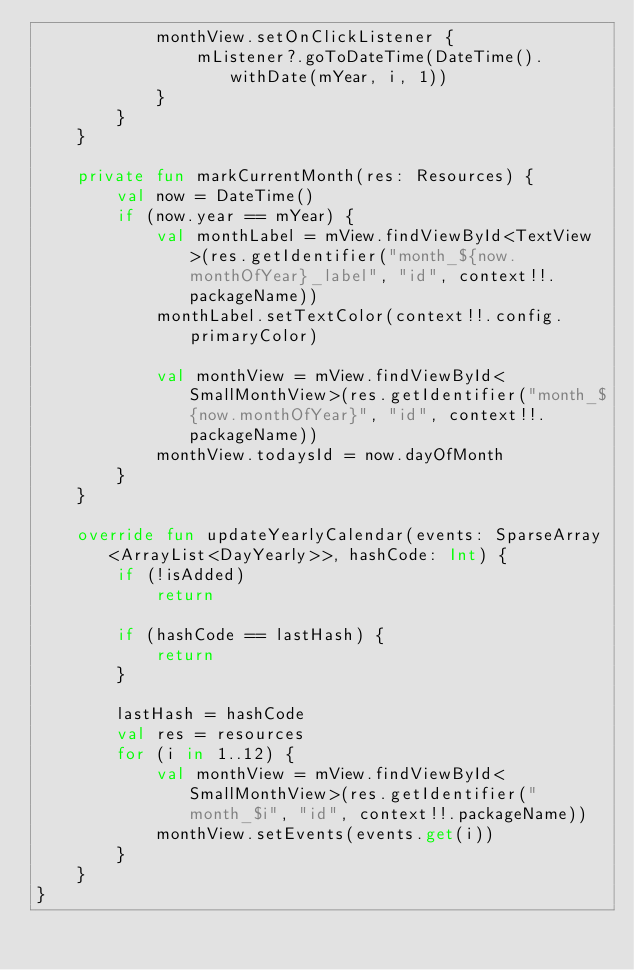<code> <loc_0><loc_0><loc_500><loc_500><_Kotlin_>            monthView.setOnClickListener {
                mListener?.goToDateTime(DateTime().withDate(mYear, i, 1))
            }
        }
    }

    private fun markCurrentMonth(res: Resources) {
        val now = DateTime()
        if (now.year == mYear) {
            val monthLabel = mView.findViewById<TextView>(res.getIdentifier("month_${now.monthOfYear}_label", "id", context!!.packageName))
            monthLabel.setTextColor(context!!.config.primaryColor)

            val monthView = mView.findViewById<SmallMonthView>(res.getIdentifier("month_${now.monthOfYear}", "id", context!!.packageName))
            monthView.todaysId = now.dayOfMonth
        }
    }

    override fun updateYearlyCalendar(events: SparseArray<ArrayList<DayYearly>>, hashCode: Int) {
        if (!isAdded)
            return

        if (hashCode == lastHash) {
            return
        }

        lastHash = hashCode
        val res = resources
        for (i in 1..12) {
            val monthView = mView.findViewById<SmallMonthView>(res.getIdentifier("month_$i", "id", context!!.packageName))
            monthView.setEvents(events.get(i))
        }
    }
}
</code> 